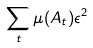Convert formula to latex. <formula><loc_0><loc_0><loc_500><loc_500>\sum _ { t } \mu ( A _ { t } ) \epsilon ^ { 2 }</formula> 